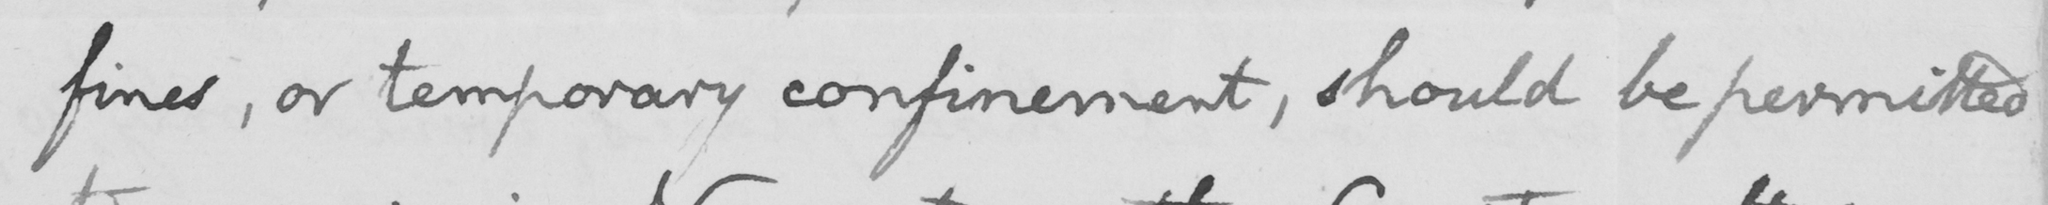What does this handwritten line say? fines, or temporary confinement, should be permitted 